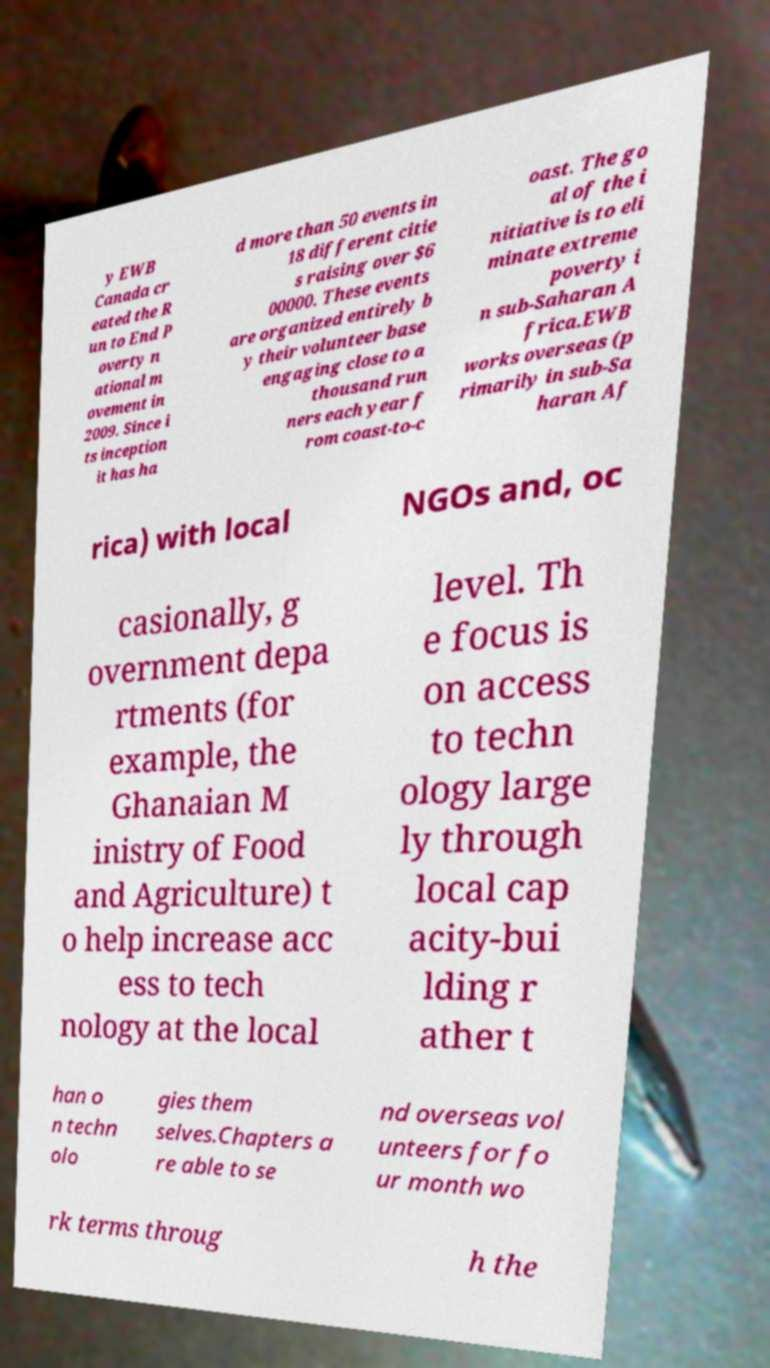Could you extract and type out the text from this image? y EWB Canada cr eated the R un to End P overty n ational m ovement in 2009. Since i ts inception it has ha d more than 50 events in 18 different citie s raising over $6 00000. These events are organized entirely b y their volunteer base engaging close to a thousand run ners each year f rom coast-to-c oast. The go al of the i nitiative is to eli minate extreme poverty i n sub-Saharan A frica.EWB works overseas (p rimarily in sub-Sa haran Af rica) with local NGOs and, oc casionally, g overnment depa rtments (for example, the Ghanaian M inistry of Food and Agriculture) t o help increase acc ess to tech nology at the local level. Th e focus is on access to techn ology large ly through local cap acity-bui lding r ather t han o n techn olo gies them selves.Chapters a re able to se nd overseas vol unteers for fo ur month wo rk terms throug h the 